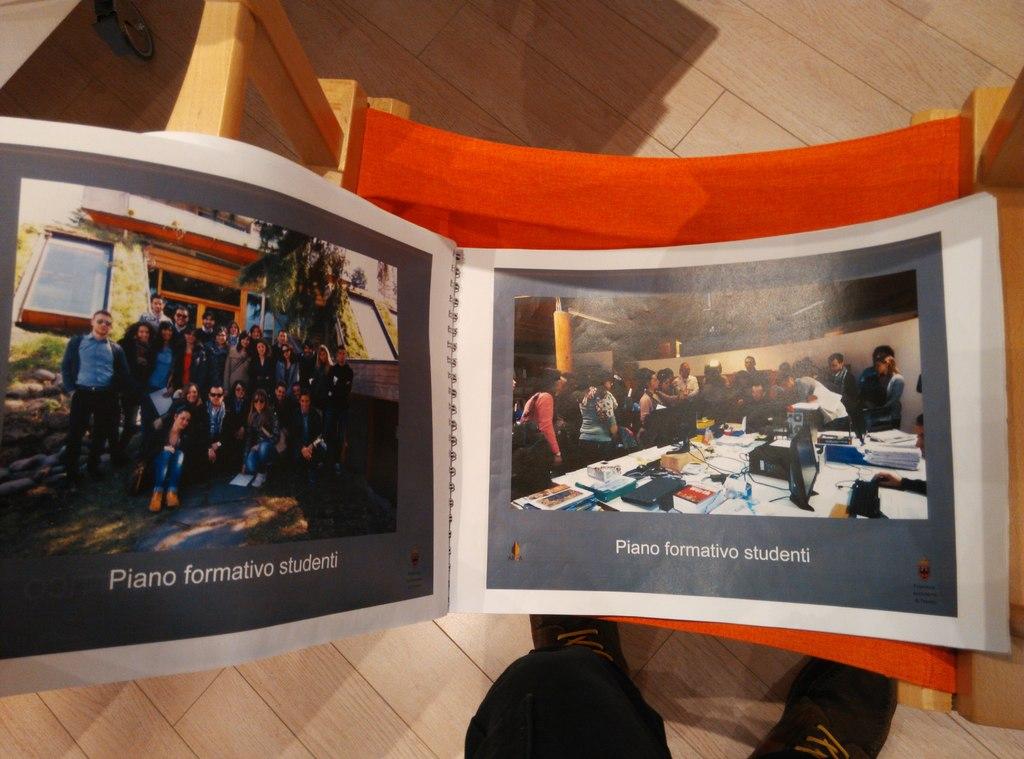What instrument is mentioned?
Provide a short and direct response. Piano. 